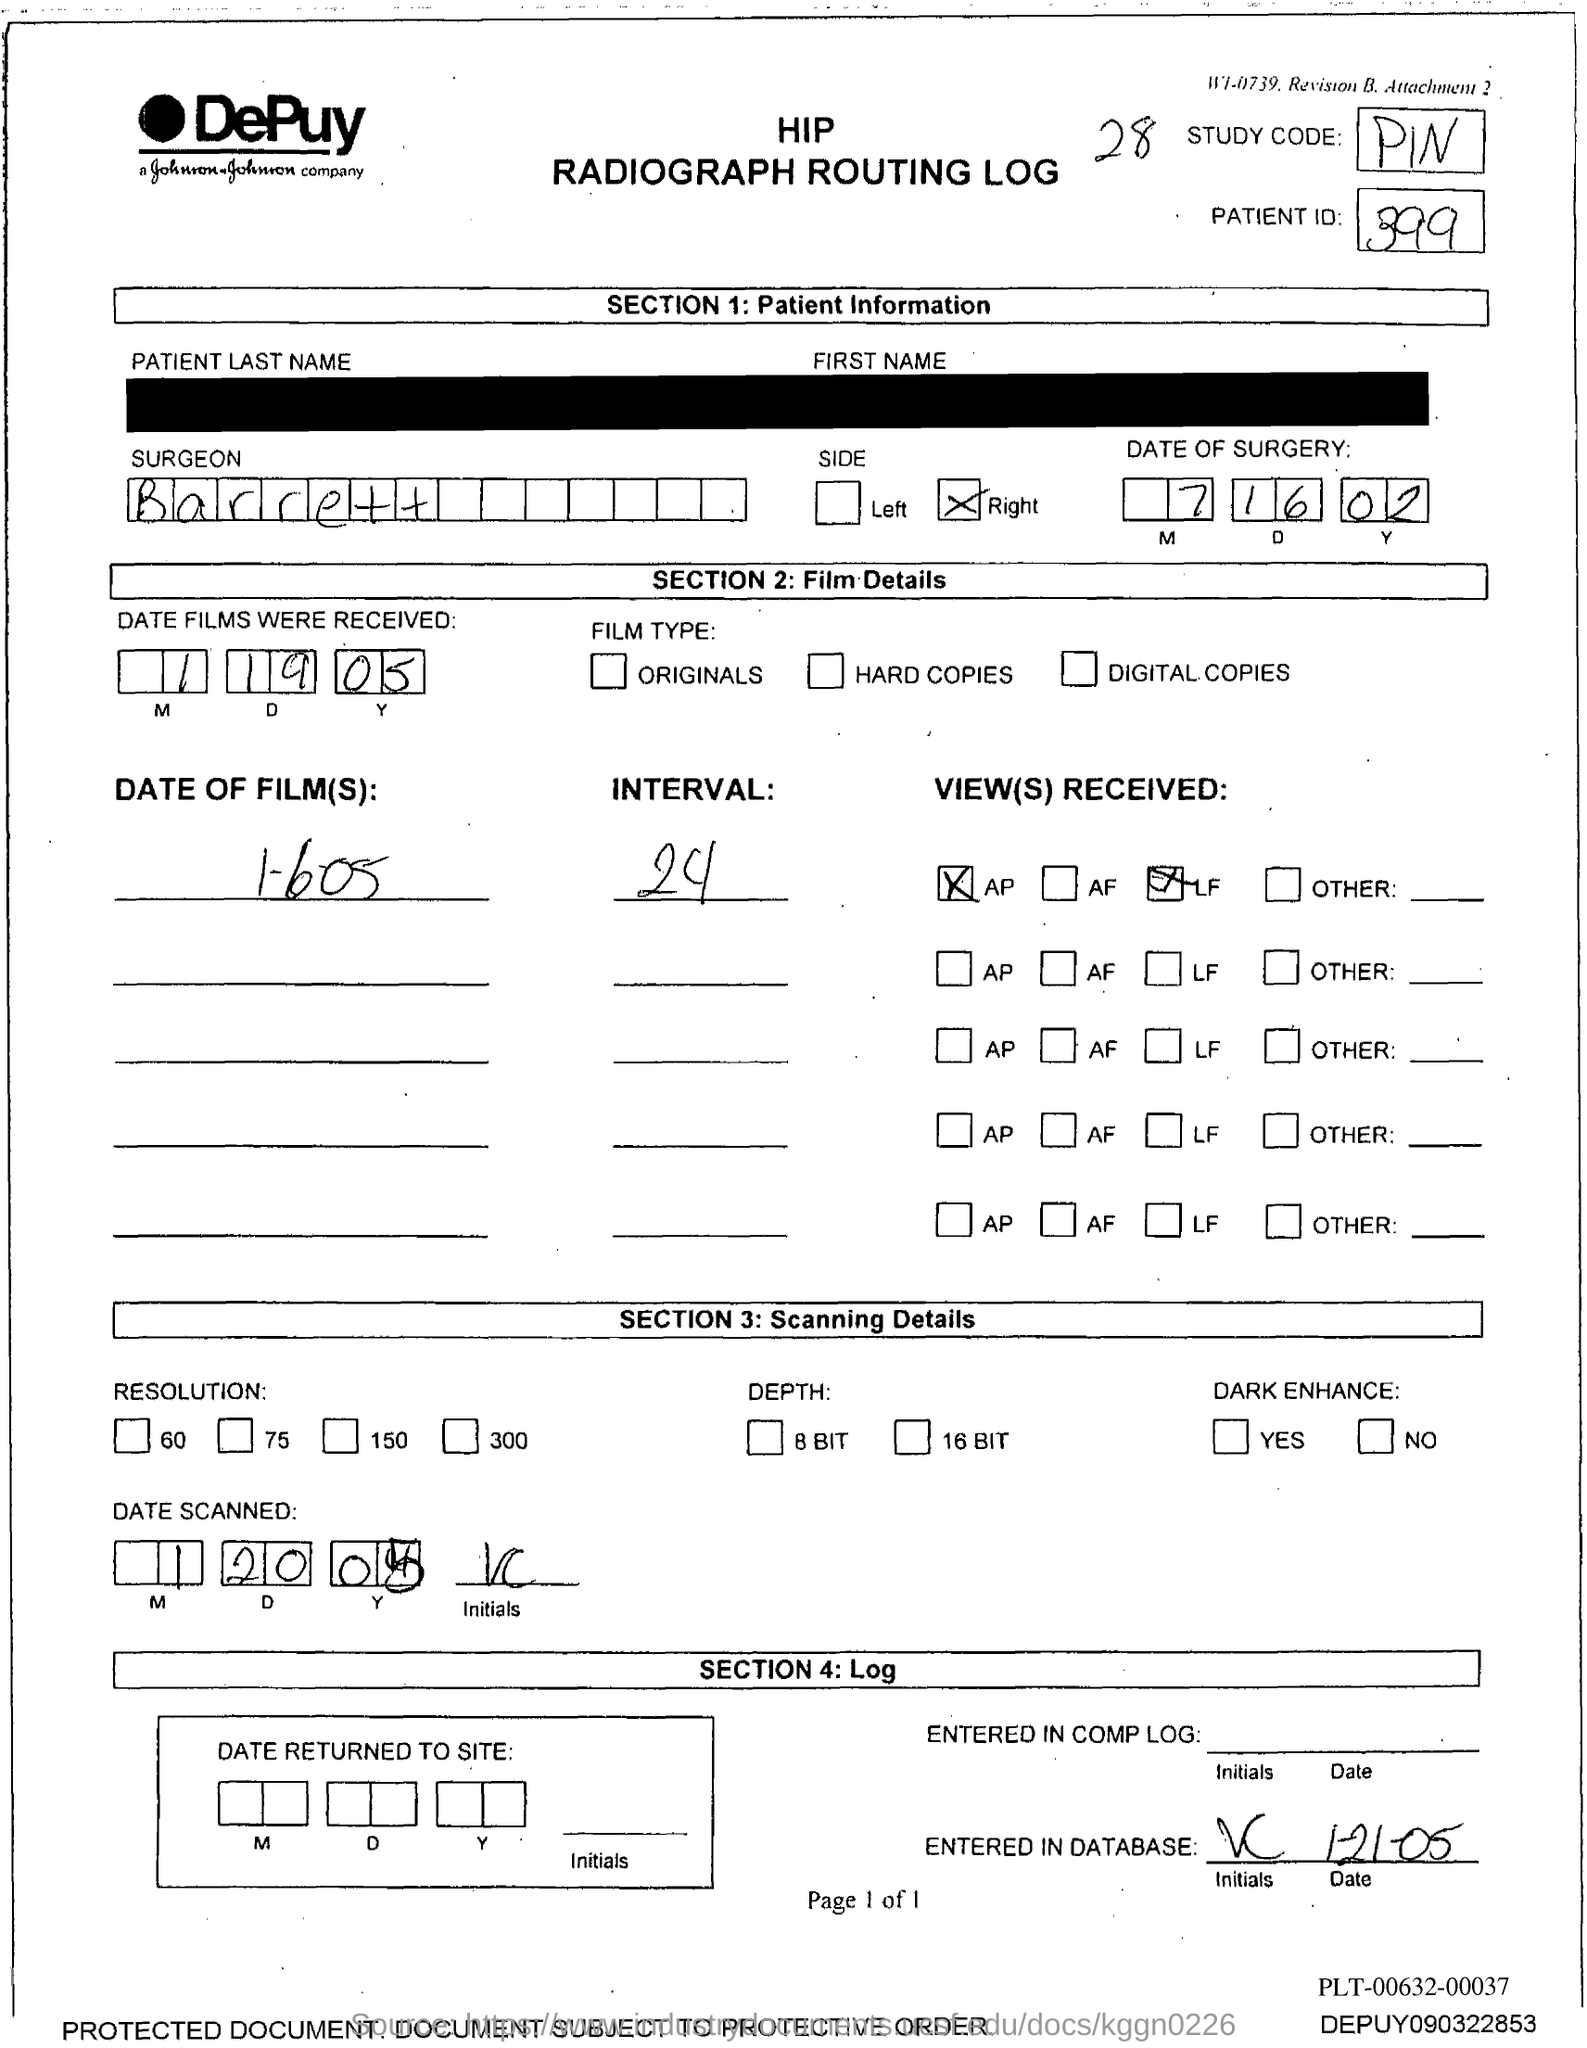What is the study code?
Offer a terse response. PIN. What is the patient id?
Give a very brief answer. 399. What is the name of surgeon ?
Make the answer very short. Barrett. 